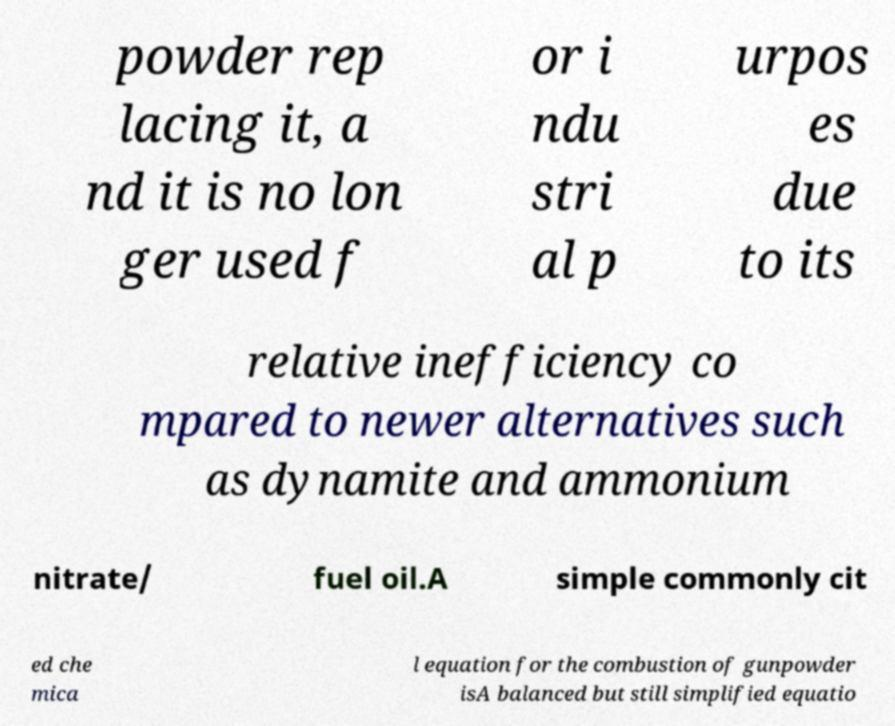Could you assist in decoding the text presented in this image and type it out clearly? powder rep lacing it, a nd it is no lon ger used f or i ndu stri al p urpos es due to its relative inefficiency co mpared to newer alternatives such as dynamite and ammonium nitrate/ fuel oil.A simple commonly cit ed che mica l equation for the combustion of gunpowder isA balanced but still simplified equatio 